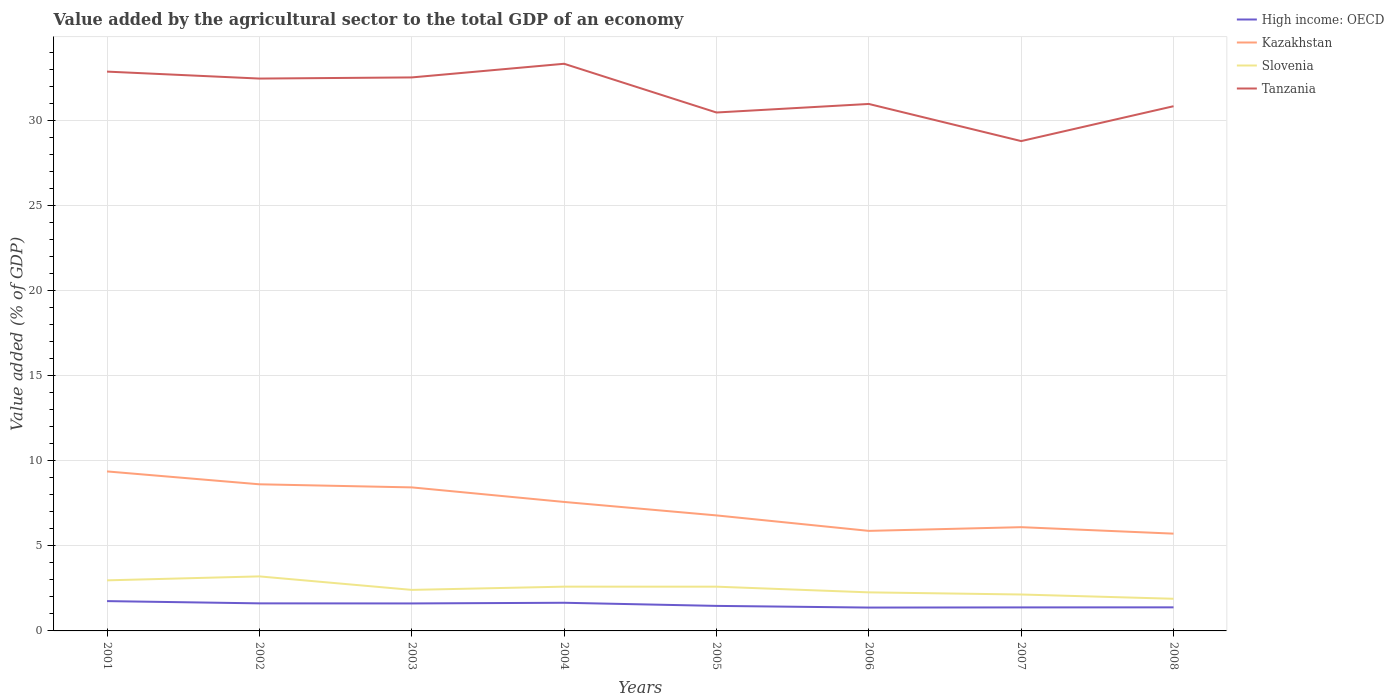How many different coloured lines are there?
Offer a very short reply. 4. Is the number of lines equal to the number of legend labels?
Provide a short and direct response. Yes. Across all years, what is the maximum value added by the agricultural sector to the total GDP in Kazakhstan?
Provide a succinct answer. 5.72. In which year was the value added by the agricultural sector to the total GDP in Slovenia maximum?
Offer a terse response. 2008. What is the total value added by the agricultural sector to the total GDP in Tanzania in the graph?
Ensure brevity in your answer.  3.74. What is the difference between the highest and the second highest value added by the agricultural sector to the total GDP in Slovenia?
Offer a terse response. 1.31. Is the value added by the agricultural sector to the total GDP in Kazakhstan strictly greater than the value added by the agricultural sector to the total GDP in Tanzania over the years?
Offer a very short reply. Yes. How many lines are there?
Offer a terse response. 4. How many years are there in the graph?
Provide a short and direct response. 8. What is the difference between two consecutive major ticks on the Y-axis?
Give a very brief answer. 5. Does the graph contain any zero values?
Your answer should be compact. No. Does the graph contain grids?
Offer a terse response. Yes. Where does the legend appear in the graph?
Provide a short and direct response. Top right. What is the title of the graph?
Offer a very short reply. Value added by the agricultural sector to the total GDP of an economy. Does "Belize" appear as one of the legend labels in the graph?
Make the answer very short. No. What is the label or title of the Y-axis?
Your answer should be very brief. Value added (% of GDP). What is the Value added (% of GDP) of High income: OECD in 2001?
Your answer should be very brief. 1.75. What is the Value added (% of GDP) of Kazakhstan in 2001?
Ensure brevity in your answer.  9.37. What is the Value added (% of GDP) of Slovenia in 2001?
Give a very brief answer. 2.97. What is the Value added (% of GDP) in Tanzania in 2001?
Your response must be concise. 32.87. What is the Value added (% of GDP) of High income: OECD in 2002?
Make the answer very short. 1.62. What is the Value added (% of GDP) of Kazakhstan in 2002?
Keep it short and to the point. 8.62. What is the Value added (% of GDP) of Slovenia in 2002?
Give a very brief answer. 3.2. What is the Value added (% of GDP) in Tanzania in 2002?
Ensure brevity in your answer.  32.46. What is the Value added (% of GDP) of High income: OECD in 2003?
Make the answer very short. 1.62. What is the Value added (% of GDP) of Kazakhstan in 2003?
Offer a very short reply. 8.43. What is the Value added (% of GDP) of Slovenia in 2003?
Make the answer very short. 2.41. What is the Value added (% of GDP) in Tanzania in 2003?
Offer a very short reply. 32.53. What is the Value added (% of GDP) in High income: OECD in 2004?
Make the answer very short. 1.65. What is the Value added (% of GDP) of Kazakhstan in 2004?
Offer a terse response. 7.58. What is the Value added (% of GDP) of Slovenia in 2004?
Offer a very short reply. 2.6. What is the Value added (% of GDP) in Tanzania in 2004?
Keep it short and to the point. 33.33. What is the Value added (% of GDP) in High income: OECD in 2005?
Ensure brevity in your answer.  1.47. What is the Value added (% of GDP) of Kazakhstan in 2005?
Provide a short and direct response. 6.79. What is the Value added (% of GDP) of Slovenia in 2005?
Your response must be concise. 2.6. What is the Value added (% of GDP) in Tanzania in 2005?
Make the answer very short. 30.46. What is the Value added (% of GDP) of High income: OECD in 2006?
Keep it short and to the point. 1.37. What is the Value added (% of GDP) of Kazakhstan in 2006?
Offer a terse response. 5.88. What is the Value added (% of GDP) in Slovenia in 2006?
Give a very brief answer. 2.27. What is the Value added (% of GDP) of Tanzania in 2006?
Make the answer very short. 30.97. What is the Value added (% of GDP) in High income: OECD in 2007?
Make the answer very short. 1.38. What is the Value added (% of GDP) of Kazakhstan in 2007?
Your response must be concise. 6.1. What is the Value added (% of GDP) in Slovenia in 2007?
Your answer should be very brief. 2.14. What is the Value added (% of GDP) of Tanzania in 2007?
Provide a succinct answer. 28.78. What is the Value added (% of GDP) in High income: OECD in 2008?
Ensure brevity in your answer.  1.39. What is the Value added (% of GDP) of Kazakhstan in 2008?
Offer a very short reply. 5.72. What is the Value added (% of GDP) in Slovenia in 2008?
Offer a terse response. 1.89. What is the Value added (% of GDP) of Tanzania in 2008?
Offer a terse response. 30.83. Across all years, what is the maximum Value added (% of GDP) in High income: OECD?
Make the answer very short. 1.75. Across all years, what is the maximum Value added (% of GDP) of Kazakhstan?
Keep it short and to the point. 9.37. Across all years, what is the maximum Value added (% of GDP) in Slovenia?
Give a very brief answer. 3.2. Across all years, what is the maximum Value added (% of GDP) of Tanzania?
Provide a succinct answer. 33.33. Across all years, what is the minimum Value added (% of GDP) in High income: OECD?
Provide a short and direct response. 1.37. Across all years, what is the minimum Value added (% of GDP) of Kazakhstan?
Provide a short and direct response. 5.72. Across all years, what is the minimum Value added (% of GDP) of Slovenia?
Offer a terse response. 1.89. Across all years, what is the minimum Value added (% of GDP) in Tanzania?
Keep it short and to the point. 28.78. What is the total Value added (% of GDP) in High income: OECD in the graph?
Offer a very short reply. 12.25. What is the total Value added (% of GDP) in Kazakhstan in the graph?
Keep it short and to the point. 58.48. What is the total Value added (% of GDP) of Slovenia in the graph?
Offer a very short reply. 20.08. What is the total Value added (% of GDP) in Tanzania in the graph?
Offer a terse response. 252.23. What is the difference between the Value added (% of GDP) of High income: OECD in 2001 and that in 2002?
Provide a succinct answer. 0.13. What is the difference between the Value added (% of GDP) in Kazakhstan in 2001 and that in 2002?
Your answer should be very brief. 0.76. What is the difference between the Value added (% of GDP) in Slovenia in 2001 and that in 2002?
Ensure brevity in your answer.  -0.23. What is the difference between the Value added (% of GDP) in Tanzania in 2001 and that in 2002?
Your answer should be very brief. 0.41. What is the difference between the Value added (% of GDP) in High income: OECD in 2001 and that in 2003?
Provide a short and direct response. 0.14. What is the difference between the Value added (% of GDP) in Kazakhstan in 2001 and that in 2003?
Ensure brevity in your answer.  0.94. What is the difference between the Value added (% of GDP) of Slovenia in 2001 and that in 2003?
Offer a very short reply. 0.56. What is the difference between the Value added (% of GDP) of Tanzania in 2001 and that in 2003?
Give a very brief answer. 0.34. What is the difference between the Value added (% of GDP) of High income: OECD in 2001 and that in 2004?
Give a very brief answer. 0.1. What is the difference between the Value added (% of GDP) of Kazakhstan in 2001 and that in 2004?
Your answer should be compact. 1.79. What is the difference between the Value added (% of GDP) of Slovenia in 2001 and that in 2004?
Provide a succinct answer. 0.37. What is the difference between the Value added (% of GDP) of Tanzania in 2001 and that in 2004?
Provide a succinct answer. -0.46. What is the difference between the Value added (% of GDP) of High income: OECD in 2001 and that in 2005?
Your answer should be compact. 0.28. What is the difference between the Value added (% of GDP) in Kazakhstan in 2001 and that in 2005?
Your response must be concise. 2.58. What is the difference between the Value added (% of GDP) in Slovenia in 2001 and that in 2005?
Your answer should be very brief. 0.37. What is the difference between the Value added (% of GDP) in Tanzania in 2001 and that in 2005?
Offer a very short reply. 2.4. What is the difference between the Value added (% of GDP) of High income: OECD in 2001 and that in 2006?
Your response must be concise. 0.38. What is the difference between the Value added (% of GDP) in Kazakhstan in 2001 and that in 2006?
Ensure brevity in your answer.  3.49. What is the difference between the Value added (% of GDP) in Slovenia in 2001 and that in 2006?
Offer a very short reply. 0.71. What is the difference between the Value added (% of GDP) in Tanzania in 2001 and that in 2006?
Provide a succinct answer. 1.9. What is the difference between the Value added (% of GDP) in High income: OECD in 2001 and that in 2007?
Your answer should be very brief. 0.37. What is the difference between the Value added (% of GDP) of Kazakhstan in 2001 and that in 2007?
Offer a terse response. 3.28. What is the difference between the Value added (% of GDP) of Slovenia in 2001 and that in 2007?
Give a very brief answer. 0.83. What is the difference between the Value added (% of GDP) of Tanzania in 2001 and that in 2007?
Provide a succinct answer. 4.08. What is the difference between the Value added (% of GDP) of High income: OECD in 2001 and that in 2008?
Your answer should be very brief. 0.37. What is the difference between the Value added (% of GDP) of Kazakhstan in 2001 and that in 2008?
Provide a succinct answer. 3.66. What is the difference between the Value added (% of GDP) in Slovenia in 2001 and that in 2008?
Give a very brief answer. 1.08. What is the difference between the Value added (% of GDP) in Tanzania in 2001 and that in 2008?
Offer a terse response. 2.03. What is the difference between the Value added (% of GDP) in High income: OECD in 2002 and that in 2003?
Your answer should be very brief. 0. What is the difference between the Value added (% of GDP) of Kazakhstan in 2002 and that in 2003?
Your answer should be very brief. 0.18. What is the difference between the Value added (% of GDP) of Slovenia in 2002 and that in 2003?
Provide a short and direct response. 0.79. What is the difference between the Value added (% of GDP) in Tanzania in 2002 and that in 2003?
Offer a very short reply. -0.07. What is the difference between the Value added (% of GDP) in High income: OECD in 2002 and that in 2004?
Keep it short and to the point. -0.03. What is the difference between the Value added (% of GDP) of Kazakhstan in 2002 and that in 2004?
Your answer should be compact. 1.04. What is the difference between the Value added (% of GDP) in Slovenia in 2002 and that in 2004?
Your answer should be very brief. 0.6. What is the difference between the Value added (% of GDP) in Tanzania in 2002 and that in 2004?
Your answer should be compact. -0.87. What is the difference between the Value added (% of GDP) of High income: OECD in 2002 and that in 2005?
Your answer should be very brief. 0.15. What is the difference between the Value added (% of GDP) in Kazakhstan in 2002 and that in 2005?
Your answer should be compact. 1.83. What is the difference between the Value added (% of GDP) in Slovenia in 2002 and that in 2005?
Provide a short and direct response. 0.6. What is the difference between the Value added (% of GDP) in Tanzania in 2002 and that in 2005?
Your answer should be very brief. 1.99. What is the difference between the Value added (% of GDP) in High income: OECD in 2002 and that in 2006?
Your answer should be compact. 0.25. What is the difference between the Value added (% of GDP) of Kazakhstan in 2002 and that in 2006?
Your answer should be compact. 2.74. What is the difference between the Value added (% of GDP) in Slovenia in 2002 and that in 2006?
Give a very brief answer. 0.94. What is the difference between the Value added (% of GDP) in Tanzania in 2002 and that in 2006?
Make the answer very short. 1.49. What is the difference between the Value added (% of GDP) in High income: OECD in 2002 and that in 2007?
Ensure brevity in your answer.  0.24. What is the difference between the Value added (% of GDP) of Kazakhstan in 2002 and that in 2007?
Give a very brief answer. 2.52. What is the difference between the Value added (% of GDP) in Slovenia in 2002 and that in 2007?
Give a very brief answer. 1.06. What is the difference between the Value added (% of GDP) in Tanzania in 2002 and that in 2007?
Provide a short and direct response. 3.67. What is the difference between the Value added (% of GDP) in High income: OECD in 2002 and that in 2008?
Your answer should be very brief. 0.23. What is the difference between the Value added (% of GDP) of Kazakhstan in 2002 and that in 2008?
Offer a very short reply. 2.9. What is the difference between the Value added (% of GDP) of Slovenia in 2002 and that in 2008?
Give a very brief answer. 1.31. What is the difference between the Value added (% of GDP) in Tanzania in 2002 and that in 2008?
Provide a succinct answer. 1.62. What is the difference between the Value added (% of GDP) in High income: OECD in 2003 and that in 2004?
Provide a succinct answer. -0.04. What is the difference between the Value added (% of GDP) of Kazakhstan in 2003 and that in 2004?
Your answer should be very brief. 0.86. What is the difference between the Value added (% of GDP) of Slovenia in 2003 and that in 2004?
Keep it short and to the point. -0.19. What is the difference between the Value added (% of GDP) in Tanzania in 2003 and that in 2004?
Offer a terse response. -0.8. What is the difference between the Value added (% of GDP) of High income: OECD in 2003 and that in 2005?
Your answer should be very brief. 0.14. What is the difference between the Value added (% of GDP) in Kazakhstan in 2003 and that in 2005?
Offer a very short reply. 1.65. What is the difference between the Value added (% of GDP) in Slovenia in 2003 and that in 2005?
Keep it short and to the point. -0.19. What is the difference between the Value added (% of GDP) of Tanzania in 2003 and that in 2005?
Keep it short and to the point. 2.06. What is the difference between the Value added (% of GDP) in High income: OECD in 2003 and that in 2006?
Offer a terse response. 0.24. What is the difference between the Value added (% of GDP) in Kazakhstan in 2003 and that in 2006?
Make the answer very short. 2.56. What is the difference between the Value added (% of GDP) of Slovenia in 2003 and that in 2006?
Your answer should be very brief. 0.15. What is the difference between the Value added (% of GDP) in Tanzania in 2003 and that in 2006?
Provide a short and direct response. 1.56. What is the difference between the Value added (% of GDP) in High income: OECD in 2003 and that in 2007?
Make the answer very short. 0.23. What is the difference between the Value added (% of GDP) of Kazakhstan in 2003 and that in 2007?
Make the answer very short. 2.34. What is the difference between the Value added (% of GDP) in Slovenia in 2003 and that in 2007?
Make the answer very short. 0.27. What is the difference between the Value added (% of GDP) in Tanzania in 2003 and that in 2007?
Offer a terse response. 3.74. What is the difference between the Value added (% of GDP) in High income: OECD in 2003 and that in 2008?
Give a very brief answer. 0.23. What is the difference between the Value added (% of GDP) in Kazakhstan in 2003 and that in 2008?
Make the answer very short. 2.72. What is the difference between the Value added (% of GDP) of Slovenia in 2003 and that in 2008?
Provide a succinct answer. 0.52. What is the difference between the Value added (% of GDP) in Tanzania in 2003 and that in 2008?
Offer a very short reply. 1.69. What is the difference between the Value added (% of GDP) in High income: OECD in 2004 and that in 2005?
Provide a succinct answer. 0.18. What is the difference between the Value added (% of GDP) of Kazakhstan in 2004 and that in 2005?
Ensure brevity in your answer.  0.79. What is the difference between the Value added (% of GDP) of Slovenia in 2004 and that in 2005?
Give a very brief answer. 0. What is the difference between the Value added (% of GDP) of Tanzania in 2004 and that in 2005?
Your response must be concise. 2.86. What is the difference between the Value added (% of GDP) in High income: OECD in 2004 and that in 2006?
Keep it short and to the point. 0.28. What is the difference between the Value added (% of GDP) in Kazakhstan in 2004 and that in 2006?
Your answer should be very brief. 1.7. What is the difference between the Value added (% of GDP) of Slovenia in 2004 and that in 2006?
Ensure brevity in your answer.  0.34. What is the difference between the Value added (% of GDP) in Tanzania in 2004 and that in 2006?
Your answer should be compact. 2.36. What is the difference between the Value added (% of GDP) in High income: OECD in 2004 and that in 2007?
Give a very brief answer. 0.27. What is the difference between the Value added (% of GDP) of Kazakhstan in 2004 and that in 2007?
Offer a very short reply. 1.48. What is the difference between the Value added (% of GDP) in Slovenia in 2004 and that in 2007?
Offer a very short reply. 0.46. What is the difference between the Value added (% of GDP) of Tanzania in 2004 and that in 2007?
Ensure brevity in your answer.  4.54. What is the difference between the Value added (% of GDP) of High income: OECD in 2004 and that in 2008?
Offer a terse response. 0.27. What is the difference between the Value added (% of GDP) of Kazakhstan in 2004 and that in 2008?
Provide a short and direct response. 1.86. What is the difference between the Value added (% of GDP) in Slovenia in 2004 and that in 2008?
Offer a very short reply. 0.71. What is the difference between the Value added (% of GDP) of Tanzania in 2004 and that in 2008?
Give a very brief answer. 2.49. What is the difference between the Value added (% of GDP) in High income: OECD in 2005 and that in 2006?
Ensure brevity in your answer.  0.1. What is the difference between the Value added (% of GDP) in Kazakhstan in 2005 and that in 2006?
Provide a succinct answer. 0.91. What is the difference between the Value added (% of GDP) of Slovenia in 2005 and that in 2006?
Offer a very short reply. 0.33. What is the difference between the Value added (% of GDP) in Tanzania in 2005 and that in 2006?
Give a very brief answer. -0.5. What is the difference between the Value added (% of GDP) of High income: OECD in 2005 and that in 2007?
Offer a very short reply. 0.09. What is the difference between the Value added (% of GDP) in Kazakhstan in 2005 and that in 2007?
Offer a very short reply. 0.69. What is the difference between the Value added (% of GDP) in Slovenia in 2005 and that in 2007?
Ensure brevity in your answer.  0.46. What is the difference between the Value added (% of GDP) of Tanzania in 2005 and that in 2007?
Keep it short and to the point. 1.68. What is the difference between the Value added (% of GDP) of High income: OECD in 2005 and that in 2008?
Provide a short and direct response. 0.09. What is the difference between the Value added (% of GDP) in Kazakhstan in 2005 and that in 2008?
Provide a short and direct response. 1.07. What is the difference between the Value added (% of GDP) in Slovenia in 2005 and that in 2008?
Offer a terse response. 0.71. What is the difference between the Value added (% of GDP) of Tanzania in 2005 and that in 2008?
Your answer should be very brief. -0.37. What is the difference between the Value added (% of GDP) in High income: OECD in 2006 and that in 2007?
Your response must be concise. -0.01. What is the difference between the Value added (% of GDP) in Kazakhstan in 2006 and that in 2007?
Provide a short and direct response. -0.22. What is the difference between the Value added (% of GDP) in Slovenia in 2006 and that in 2007?
Your answer should be very brief. 0.13. What is the difference between the Value added (% of GDP) of Tanzania in 2006 and that in 2007?
Your answer should be compact. 2.18. What is the difference between the Value added (% of GDP) in High income: OECD in 2006 and that in 2008?
Give a very brief answer. -0.01. What is the difference between the Value added (% of GDP) of Kazakhstan in 2006 and that in 2008?
Keep it short and to the point. 0.16. What is the difference between the Value added (% of GDP) of Slovenia in 2006 and that in 2008?
Make the answer very short. 0.38. What is the difference between the Value added (% of GDP) of Tanzania in 2006 and that in 2008?
Offer a very short reply. 0.13. What is the difference between the Value added (% of GDP) of High income: OECD in 2007 and that in 2008?
Give a very brief answer. -0. What is the difference between the Value added (% of GDP) of Kazakhstan in 2007 and that in 2008?
Your response must be concise. 0.38. What is the difference between the Value added (% of GDP) of Slovenia in 2007 and that in 2008?
Your response must be concise. 0.25. What is the difference between the Value added (% of GDP) in Tanzania in 2007 and that in 2008?
Your response must be concise. -2.05. What is the difference between the Value added (% of GDP) of High income: OECD in 2001 and the Value added (% of GDP) of Kazakhstan in 2002?
Your answer should be very brief. -6.86. What is the difference between the Value added (% of GDP) of High income: OECD in 2001 and the Value added (% of GDP) of Slovenia in 2002?
Ensure brevity in your answer.  -1.45. What is the difference between the Value added (% of GDP) in High income: OECD in 2001 and the Value added (% of GDP) in Tanzania in 2002?
Offer a very short reply. -30.71. What is the difference between the Value added (% of GDP) in Kazakhstan in 2001 and the Value added (% of GDP) in Slovenia in 2002?
Offer a terse response. 6.17. What is the difference between the Value added (% of GDP) of Kazakhstan in 2001 and the Value added (% of GDP) of Tanzania in 2002?
Your response must be concise. -23.09. What is the difference between the Value added (% of GDP) in Slovenia in 2001 and the Value added (% of GDP) in Tanzania in 2002?
Make the answer very short. -29.49. What is the difference between the Value added (% of GDP) of High income: OECD in 2001 and the Value added (% of GDP) of Kazakhstan in 2003?
Provide a succinct answer. -6.68. What is the difference between the Value added (% of GDP) in High income: OECD in 2001 and the Value added (% of GDP) in Slovenia in 2003?
Ensure brevity in your answer.  -0.66. What is the difference between the Value added (% of GDP) of High income: OECD in 2001 and the Value added (% of GDP) of Tanzania in 2003?
Give a very brief answer. -30.77. What is the difference between the Value added (% of GDP) in Kazakhstan in 2001 and the Value added (% of GDP) in Slovenia in 2003?
Give a very brief answer. 6.96. What is the difference between the Value added (% of GDP) in Kazakhstan in 2001 and the Value added (% of GDP) in Tanzania in 2003?
Make the answer very short. -23.15. What is the difference between the Value added (% of GDP) in Slovenia in 2001 and the Value added (% of GDP) in Tanzania in 2003?
Give a very brief answer. -29.55. What is the difference between the Value added (% of GDP) in High income: OECD in 2001 and the Value added (% of GDP) in Kazakhstan in 2004?
Your answer should be compact. -5.83. What is the difference between the Value added (% of GDP) of High income: OECD in 2001 and the Value added (% of GDP) of Slovenia in 2004?
Ensure brevity in your answer.  -0.85. What is the difference between the Value added (% of GDP) in High income: OECD in 2001 and the Value added (% of GDP) in Tanzania in 2004?
Your answer should be very brief. -31.58. What is the difference between the Value added (% of GDP) in Kazakhstan in 2001 and the Value added (% of GDP) in Slovenia in 2004?
Keep it short and to the point. 6.77. What is the difference between the Value added (% of GDP) in Kazakhstan in 2001 and the Value added (% of GDP) in Tanzania in 2004?
Give a very brief answer. -23.96. What is the difference between the Value added (% of GDP) of Slovenia in 2001 and the Value added (% of GDP) of Tanzania in 2004?
Your answer should be very brief. -30.36. What is the difference between the Value added (% of GDP) in High income: OECD in 2001 and the Value added (% of GDP) in Kazakhstan in 2005?
Give a very brief answer. -5.04. What is the difference between the Value added (% of GDP) of High income: OECD in 2001 and the Value added (% of GDP) of Slovenia in 2005?
Offer a terse response. -0.85. What is the difference between the Value added (% of GDP) of High income: OECD in 2001 and the Value added (% of GDP) of Tanzania in 2005?
Your answer should be very brief. -28.71. What is the difference between the Value added (% of GDP) of Kazakhstan in 2001 and the Value added (% of GDP) of Slovenia in 2005?
Ensure brevity in your answer.  6.77. What is the difference between the Value added (% of GDP) of Kazakhstan in 2001 and the Value added (% of GDP) of Tanzania in 2005?
Your answer should be compact. -21.09. What is the difference between the Value added (% of GDP) in Slovenia in 2001 and the Value added (% of GDP) in Tanzania in 2005?
Make the answer very short. -27.49. What is the difference between the Value added (% of GDP) of High income: OECD in 2001 and the Value added (% of GDP) of Kazakhstan in 2006?
Your answer should be compact. -4.13. What is the difference between the Value added (% of GDP) of High income: OECD in 2001 and the Value added (% of GDP) of Slovenia in 2006?
Your answer should be very brief. -0.51. What is the difference between the Value added (% of GDP) of High income: OECD in 2001 and the Value added (% of GDP) of Tanzania in 2006?
Your answer should be very brief. -29.21. What is the difference between the Value added (% of GDP) of Kazakhstan in 2001 and the Value added (% of GDP) of Slovenia in 2006?
Offer a terse response. 7.11. What is the difference between the Value added (% of GDP) of Kazakhstan in 2001 and the Value added (% of GDP) of Tanzania in 2006?
Make the answer very short. -21.59. What is the difference between the Value added (% of GDP) of Slovenia in 2001 and the Value added (% of GDP) of Tanzania in 2006?
Ensure brevity in your answer.  -27.99. What is the difference between the Value added (% of GDP) in High income: OECD in 2001 and the Value added (% of GDP) in Kazakhstan in 2007?
Your response must be concise. -4.34. What is the difference between the Value added (% of GDP) of High income: OECD in 2001 and the Value added (% of GDP) of Slovenia in 2007?
Make the answer very short. -0.39. What is the difference between the Value added (% of GDP) in High income: OECD in 2001 and the Value added (% of GDP) in Tanzania in 2007?
Ensure brevity in your answer.  -27.03. What is the difference between the Value added (% of GDP) in Kazakhstan in 2001 and the Value added (% of GDP) in Slovenia in 2007?
Your answer should be compact. 7.23. What is the difference between the Value added (% of GDP) of Kazakhstan in 2001 and the Value added (% of GDP) of Tanzania in 2007?
Your response must be concise. -19.41. What is the difference between the Value added (% of GDP) of Slovenia in 2001 and the Value added (% of GDP) of Tanzania in 2007?
Provide a succinct answer. -25.81. What is the difference between the Value added (% of GDP) of High income: OECD in 2001 and the Value added (% of GDP) of Kazakhstan in 2008?
Your answer should be compact. -3.96. What is the difference between the Value added (% of GDP) in High income: OECD in 2001 and the Value added (% of GDP) in Slovenia in 2008?
Your answer should be compact. -0.14. What is the difference between the Value added (% of GDP) in High income: OECD in 2001 and the Value added (% of GDP) in Tanzania in 2008?
Offer a very short reply. -29.08. What is the difference between the Value added (% of GDP) of Kazakhstan in 2001 and the Value added (% of GDP) of Slovenia in 2008?
Provide a succinct answer. 7.48. What is the difference between the Value added (% of GDP) of Kazakhstan in 2001 and the Value added (% of GDP) of Tanzania in 2008?
Provide a short and direct response. -21.46. What is the difference between the Value added (% of GDP) of Slovenia in 2001 and the Value added (% of GDP) of Tanzania in 2008?
Offer a terse response. -27.86. What is the difference between the Value added (% of GDP) in High income: OECD in 2002 and the Value added (% of GDP) in Kazakhstan in 2003?
Make the answer very short. -6.81. What is the difference between the Value added (% of GDP) of High income: OECD in 2002 and the Value added (% of GDP) of Slovenia in 2003?
Give a very brief answer. -0.79. What is the difference between the Value added (% of GDP) in High income: OECD in 2002 and the Value added (% of GDP) in Tanzania in 2003?
Provide a succinct answer. -30.91. What is the difference between the Value added (% of GDP) of Kazakhstan in 2002 and the Value added (% of GDP) of Slovenia in 2003?
Ensure brevity in your answer.  6.2. What is the difference between the Value added (% of GDP) in Kazakhstan in 2002 and the Value added (% of GDP) in Tanzania in 2003?
Keep it short and to the point. -23.91. What is the difference between the Value added (% of GDP) in Slovenia in 2002 and the Value added (% of GDP) in Tanzania in 2003?
Offer a terse response. -29.32. What is the difference between the Value added (% of GDP) in High income: OECD in 2002 and the Value added (% of GDP) in Kazakhstan in 2004?
Your answer should be compact. -5.96. What is the difference between the Value added (% of GDP) of High income: OECD in 2002 and the Value added (% of GDP) of Slovenia in 2004?
Your response must be concise. -0.98. What is the difference between the Value added (% of GDP) in High income: OECD in 2002 and the Value added (% of GDP) in Tanzania in 2004?
Provide a short and direct response. -31.71. What is the difference between the Value added (% of GDP) of Kazakhstan in 2002 and the Value added (% of GDP) of Slovenia in 2004?
Provide a succinct answer. 6.01. What is the difference between the Value added (% of GDP) of Kazakhstan in 2002 and the Value added (% of GDP) of Tanzania in 2004?
Make the answer very short. -24.71. What is the difference between the Value added (% of GDP) in Slovenia in 2002 and the Value added (% of GDP) in Tanzania in 2004?
Provide a short and direct response. -30.12. What is the difference between the Value added (% of GDP) in High income: OECD in 2002 and the Value added (% of GDP) in Kazakhstan in 2005?
Offer a very short reply. -5.17. What is the difference between the Value added (% of GDP) in High income: OECD in 2002 and the Value added (% of GDP) in Slovenia in 2005?
Provide a short and direct response. -0.98. What is the difference between the Value added (% of GDP) of High income: OECD in 2002 and the Value added (% of GDP) of Tanzania in 2005?
Your answer should be compact. -28.84. What is the difference between the Value added (% of GDP) in Kazakhstan in 2002 and the Value added (% of GDP) in Slovenia in 2005?
Provide a short and direct response. 6.02. What is the difference between the Value added (% of GDP) in Kazakhstan in 2002 and the Value added (% of GDP) in Tanzania in 2005?
Make the answer very short. -21.85. What is the difference between the Value added (% of GDP) in Slovenia in 2002 and the Value added (% of GDP) in Tanzania in 2005?
Your response must be concise. -27.26. What is the difference between the Value added (% of GDP) in High income: OECD in 2002 and the Value added (% of GDP) in Kazakhstan in 2006?
Give a very brief answer. -4.26. What is the difference between the Value added (% of GDP) in High income: OECD in 2002 and the Value added (% of GDP) in Slovenia in 2006?
Provide a short and direct response. -0.65. What is the difference between the Value added (% of GDP) in High income: OECD in 2002 and the Value added (% of GDP) in Tanzania in 2006?
Keep it short and to the point. -29.35. What is the difference between the Value added (% of GDP) in Kazakhstan in 2002 and the Value added (% of GDP) in Slovenia in 2006?
Ensure brevity in your answer.  6.35. What is the difference between the Value added (% of GDP) in Kazakhstan in 2002 and the Value added (% of GDP) in Tanzania in 2006?
Ensure brevity in your answer.  -22.35. What is the difference between the Value added (% of GDP) in Slovenia in 2002 and the Value added (% of GDP) in Tanzania in 2006?
Provide a succinct answer. -27.76. What is the difference between the Value added (% of GDP) in High income: OECD in 2002 and the Value added (% of GDP) in Kazakhstan in 2007?
Provide a short and direct response. -4.48. What is the difference between the Value added (% of GDP) of High income: OECD in 2002 and the Value added (% of GDP) of Slovenia in 2007?
Your response must be concise. -0.52. What is the difference between the Value added (% of GDP) of High income: OECD in 2002 and the Value added (% of GDP) of Tanzania in 2007?
Provide a succinct answer. -27.16. What is the difference between the Value added (% of GDP) of Kazakhstan in 2002 and the Value added (% of GDP) of Slovenia in 2007?
Offer a terse response. 6.48. What is the difference between the Value added (% of GDP) of Kazakhstan in 2002 and the Value added (% of GDP) of Tanzania in 2007?
Provide a short and direct response. -20.17. What is the difference between the Value added (% of GDP) of Slovenia in 2002 and the Value added (% of GDP) of Tanzania in 2007?
Offer a terse response. -25.58. What is the difference between the Value added (% of GDP) of High income: OECD in 2002 and the Value added (% of GDP) of Kazakhstan in 2008?
Provide a succinct answer. -4.1. What is the difference between the Value added (% of GDP) of High income: OECD in 2002 and the Value added (% of GDP) of Slovenia in 2008?
Make the answer very short. -0.27. What is the difference between the Value added (% of GDP) of High income: OECD in 2002 and the Value added (% of GDP) of Tanzania in 2008?
Your response must be concise. -29.21. What is the difference between the Value added (% of GDP) in Kazakhstan in 2002 and the Value added (% of GDP) in Slovenia in 2008?
Give a very brief answer. 6.73. What is the difference between the Value added (% of GDP) of Kazakhstan in 2002 and the Value added (% of GDP) of Tanzania in 2008?
Provide a succinct answer. -22.22. What is the difference between the Value added (% of GDP) of Slovenia in 2002 and the Value added (% of GDP) of Tanzania in 2008?
Ensure brevity in your answer.  -27.63. What is the difference between the Value added (% of GDP) of High income: OECD in 2003 and the Value added (% of GDP) of Kazakhstan in 2004?
Your answer should be compact. -5.96. What is the difference between the Value added (% of GDP) of High income: OECD in 2003 and the Value added (% of GDP) of Slovenia in 2004?
Your answer should be very brief. -0.99. What is the difference between the Value added (% of GDP) of High income: OECD in 2003 and the Value added (% of GDP) of Tanzania in 2004?
Your answer should be compact. -31.71. What is the difference between the Value added (% of GDP) in Kazakhstan in 2003 and the Value added (% of GDP) in Slovenia in 2004?
Your answer should be very brief. 5.83. What is the difference between the Value added (% of GDP) in Kazakhstan in 2003 and the Value added (% of GDP) in Tanzania in 2004?
Provide a succinct answer. -24.89. What is the difference between the Value added (% of GDP) in Slovenia in 2003 and the Value added (% of GDP) in Tanzania in 2004?
Your answer should be very brief. -30.92. What is the difference between the Value added (% of GDP) of High income: OECD in 2003 and the Value added (% of GDP) of Kazakhstan in 2005?
Offer a very short reply. -5.17. What is the difference between the Value added (% of GDP) in High income: OECD in 2003 and the Value added (% of GDP) in Slovenia in 2005?
Make the answer very short. -0.99. What is the difference between the Value added (% of GDP) in High income: OECD in 2003 and the Value added (% of GDP) in Tanzania in 2005?
Offer a very short reply. -28.85. What is the difference between the Value added (% of GDP) of Kazakhstan in 2003 and the Value added (% of GDP) of Slovenia in 2005?
Your answer should be compact. 5.83. What is the difference between the Value added (% of GDP) of Kazakhstan in 2003 and the Value added (% of GDP) of Tanzania in 2005?
Give a very brief answer. -22.03. What is the difference between the Value added (% of GDP) in Slovenia in 2003 and the Value added (% of GDP) in Tanzania in 2005?
Keep it short and to the point. -28.05. What is the difference between the Value added (% of GDP) of High income: OECD in 2003 and the Value added (% of GDP) of Kazakhstan in 2006?
Your response must be concise. -4.26. What is the difference between the Value added (% of GDP) in High income: OECD in 2003 and the Value added (% of GDP) in Slovenia in 2006?
Your answer should be compact. -0.65. What is the difference between the Value added (% of GDP) in High income: OECD in 2003 and the Value added (% of GDP) in Tanzania in 2006?
Ensure brevity in your answer.  -29.35. What is the difference between the Value added (% of GDP) in Kazakhstan in 2003 and the Value added (% of GDP) in Slovenia in 2006?
Make the answer very short. 6.17. What is the difference between the Value added (% of GDP) of Kazakhstan in 2003 and the Value added (% of GDP) of Tanzania in 2006?
Your response must be concise. -22.53. What is the difference between the Value added (% of GDP) in Slovenia in 2003 and the Value added (% of GDP) in Tanzania in 2006?
Offer a very short reply. -28.55. What is the difference between the Value added (% of GDP) in High income: OECD in 2003 and the Value added (% of GDP) in Kazakhstan in 2007?
Ensure brevity in your answer.  -4.48. What is the difference between the Value added (% of GDP) in High income: OECD in 2003 and the Value added (% of GDP) in Slovenia in 2007?
Your response must be concise. -0.52. What is the difference between the Value added (% of GDP) in High income: OECD in 2003 and the Value added (% of GDP) in Tanzania in 2007?
Keep it short and to the point. -27.17. What is the difference between the Value added (% of GDP) in Kazakhstan in 2003 and the Value added (% of GDP) in Slovenia in 2007?
Offer a very short reply. 6.29. What is the difference between the Value added (% of GDP) of Kazakhstan in 2003 and the Value added (% of GDP) of Tanzania in 2007?
Offer a very short reply. -20.35. What is the difference between the Value added (% of GDP) in Slovenia in 2003 and the Value added (% of GDP) in Tanzania in 2007?
Your response must be concise. -26.37. What is the difference between the Value added (% of GDP) of High income: OECD in 2003 and the Value added (% of GDP) of Kazakhstan in 2008?
Your response must be concise. -4.1. What is the difference between the Value added (% of GDP) of High income: OECD in 2003 and the Value added (% of GDP) of Slovenia in 2008?
Provide a succinct answer. -0.27. What is the difference between the Value added (% of GDP) of High income: OECD in 2003 and the Value added (% of GDP) of Tanzania in 2008?
Make the answer very short. -29.22. What is the difference between the Value added (% of GDP) of Kazakhstan in 2003 and the Value added (% of GDP) of Slovenia in 2008?
Give a very brief answer. 6.54. What is the difference between the Value added (% of GDP) in Kazakhstan in 2003 and the Value added (% of GDP) in Tanzania in 2008?
Your answer should be compact. -22.4. What is the difference between the Value added (% of GDP) of Slovenia in 2003 and the Value added (% of GDP) of Tanzania in 2008?
Offer a very short reply. -28.42. What is the difference between the Value added (% of GDP) in High income: OECD in 2004 and the Value added (% of GDP) in Kazakhstan in 2005?
Ensure brevity in your answer.  -5.13. What is the difference between the Value added (% of GDP) in High income: OECD in 2004 and the Value added (% of GDP) in Slovenia in 2005?
Make the answer very short. -0.95. What is the difference between the Value added (% of GDP) in High income: OECD in 2004 and the Value added (% of GDP) in Tanzania in 2005?
Give a very brief answer. -28.81. What is the difference between the Value added (% of GDP) in Kazakhstan in 2004 and the Value added (% of GDP) in Slovenia in 2005?
Your response must be concise. 4.98. What is the difference between the Value added (% of GDP) in Kazakhstan in 2004 and the Value added (% of GDP) in Tanzania in 2005?
Provide a succinct answer. -22.89. What is the difference between the Value added (% of GDP) in Slovenia in 2004 and the Value added (% of GDP) in Tanzania in 2005?
Provide a short and direct response. -27.86. What is the difference between the Value added (% of GDP) of High income: OECD in 2004 and the Value added (% of GDP) of Kazakhstan in 2006?
Your response must be concise. -4.22. What is the difference between the Value added (% of GDP) in High income: OECD in 2004 and the Value added (% of GDP) in Slovenia in 2006?
Your response must be concise. -0.61. What is the difference between the Value added (% of GDP) in High income: OECD in 2004 and the Value added (% of GDP) in Tanzania in 2006?
Provide a succinct answer. -29.31. What is the difference between the Value added (% of GDP) in Kazakhstan in 2004 and the Value added (% of GDP) in Slovenia in 2006?
Give a very brief answer. 5.31. What is the difference between the Value added (% of GDP) of Kazakhstan in 2004 and the Value added (% of GDP) of Tanzania in 2006?
Your answer should be very brief. -23.39. What is the difference between the Value added (% of GDP) in Slovenia in 2004 and the Value added (% of GDP) in Tanzania in 2006?
Provide a succinct answer. -28.36. What is the difference between the Value added (% of GDP) of High income: OECD in 2004 and the Value added (% of GDP) of Kazakhstan in 2007?
Your response must be concise. -4.44. What is the difference between the Value added (% of GDP) in High income: OECD in 2004 and the Value added (% of GDP) in Slovenia in 2007?
Give a very brief answer. -0.49. What is the difference between the Value added (% of GDP) of High income: OECD in 2004 and the Value added (% of GDP) of Tanzania in 2007?
Provide a succinct answer. -27.13. What is the difference between the Value added (% of GDP) of Kazakhstan in 2004 and the Value added (% of GDP) of Slovenia in 2007?
Your answer should be very brief. 5.44. What is the difference between the Value added (% of GDP) of Kazakhstan in 2004 and the Value added (% of GDP) of Tanzania in 2007?
Your answer should be very brief. -21.21. What is the difference between the Value added (% of GDP) in Slovenia in 2004 and the Value added (% of GDP) in Tanzania in 2007?
Your answer should be compact. -26.18. What is the difference between the Value added (% of GDP) of High income: OECD in 2004 and the Value added (% of GDP) of Kazakhstan in 2008?
Ensure brevity in your answer.  -4.06. What is the difference between the Value added (% of GDP) of High income: OECD in 2004 and the Value added (% of GDP) of Slovenia in 2008?
Give a very brief answer. -0.24. What is the difference between the Value added (% of GDP) in High income: OECD in 2004 and the Value added (% of GDP) in Tanzania in 2008?
Provide a short and direct response. -29.18. What is the difference between the Value added (% of GDP) in Kazakhstan in 2004 and the Value added (% of GDP) in Slovenia in 2008?
Ensure brevity in your answer.  5.69. What is the difference between the Value added (% of GDP) of Kazakhstan in 2004 and the Value added (% of GDP) of Tanzania in 2008?
Your answer should be very brief. -23.25. What is the difference between the Value added (% of GDP) of Slovenia in 2004 and the Value added (% of GDP) of Tanzania in 2008?
Offer a terse response. -28.23. What is the difference between the Value added (% of GDP) of High income: OECD in 2005 and the Value added (% of GDP) of Kazakhstan in 2006?
Give a very brief answer. -4.41. What is the difference between the Value added (% of GDP) of High income: OECD in 2005 and the Value added (% of GDP) of Slovenia in 2006?
Ensure brevity in your answer.  -0.79. What is the difference between the Value added (% of GDP) of High income: OECD in 2005 and the Value added (% of GDP) of Tanzania in 2006?
Provide a short and direct response. -29.49. What is the difference between the Value added (% of GDP) in Kazakhstan in 2005 and the Value added (% of GDP) in Slovenia in 2006?
Your answer should be very brief. 4.52. What is the difference between the Value added (% of GDP) of Kazakhstan in 2005 and the Value added (% of GDP) of Tanzania in 2006?
Offer a very short reply. -24.18. What is the difference between the Value added (% of GDP) in Slovenia in 2005 and the Value added (% of GDP) in Tanzania in 2006?
Ensure brevity in your answer.  -28.37. What is the difference between the Value added (% of GDP) of High income: OECD in 2005 and the Value added (% of GDP) of Kazakhstan in 2007?
Your answer should be compact. -4.63. What is the difference between the Value added (% of GDP) of High income: OECD in 2005 and the Value added (% of GDP) of Slovenia in 2007?
Keep it short and to the point. -0.67. What is the difference between the Value added (% of GDP) of High income: OECD in 2005 and the Value added (% of GDP) of Tanzania in 2007?
Make the answer very short. -27.31. What is the difference between the Value added (% of GDP) of Kazakhstan in 2005 and the Value added (% of GDP) of Slovenia in 2007?
Your answer should be compact. 4.65. What is the difference between the Value added (% of GDP) of Kazakhstan in 2005 and the Value added (% of GDP) of Tanzania in 2007?
Give a very brief answer. -22. What is the difference between the Value added (% of GDP) of Slovenia in 2005 and the Value added (% of GDP) of Tanzania in 2007?
Provide a succinct answer. -26.18. What is the difference between the Value added (% of GDP) of High income: OECD in 2005 and the Value added (% of GDP) of Kazakhstan in 2008?
Provide a short and direct response. -4.25. What is the difference between the Value added (% of GDP) in High income: OECD in 2005 and the Value added (% of GDP) in Slovenia in 2008?
Your answer should be very brief. -0.42. What is the difference between the Value added (% of GDP) in High income: OECD in 2005 and the Value added (% of GDP) in Tanzania in 2008?
Your response must be concise. -29.36. What is the difference between the Value added (% of GDP) in Kazakhstan in 2005 and the Value added (% of GDP) in Slovenia in 2008?
Keep it short and to the point. 4.9. What is the difference between the Value added (% of GDP) in Kazakhstan in 2005 and the Value added (% of GDP) in Tanzania in 2008?
Keep it short and to the point. -24.05. What is the difference between the Value added (% of GDP) of Slovenia in 2005 and the Value added (% of GDP) of Tanzania in 2008?
Your answer should be compact. -28.23. What is the difference between the Value added (% of GDP) of High income: OECD in 2006 and the Value added (% of GDP) of Kazakhstan in 2007?
Keep it short and to the point. -4.72. What is the difference between the Value added (% of GDP) of High income: OECD in 2006 and the Value added (% of GDP) of Slovenia in 2007?
Offer a terse response. -0.77. What is the difference between the Value added (% of GDP) in High income: OECD in 2006 and the Value added (% of GDP) in Tanzania in 2007?
Offer a terse response. -27.41. What is the difference between the Value added (% of GDP) in Kazakhstan in 2006 and the Value added (% of GDP) in Slovenia in 2007?
Your response must be concise. 3.74. What is the difference between the Value added (% of GDP) of Kazakhstan in 2006 and the Value added (% of GDP) of Tanzania in 2007?
Offer a very short reply. -22.91. What is the difference between the Value added (% of GDP) of Slovenia in 2006 and the Value added (% of GDP) of Tanzania in 2007?
Provide a short and direct response. -26.52. What is the difference between the Value added (% of GDP) in High income: OECD in 2006 and the Value added (% of GDP) in Kazakhstan in 2008?
Your answer should be compact. -4.34. What is the difference between the Value added (% of GDP) of High income: OECD in 2006 and the Value added (% of GDP) of Slovenia in 2008?
Keep it short and to the point. -0.52. What is the difference between the Value added (% of GDP) in High income: OECD in 2006 and the Value added (% of GDP) in Tanzania in 2008?
Ensure brevity in your answer.  -29.46. What is the difference between the Value added (% of GDP) in Kazakhstan in 2006 and the Value added (% of GDP) in Slovenia in 2008?
Offer a terse response. 3.99. What is the difference between the Value added (% of GDP) of Kazakhstan in 2006 and the Value added (% of GDP) of Tanzania in 2008?
Offer a very short reply. -24.95. What is the difference between the Value added (% of GDP) of Slovenia in 2006 and the Value added (% of GDP) of Tanzania in 2008?
Your response must be concise. -28.57. What is the difference between the Value added (% of GDP) in High income: OECD in 2007 and the Value added (% of GDP) in Kazakhstan in 2008?
Your answer should be very brief. -4.33. What is the difference between the Value added (% of GDP) in High income: OECD in 2007 and the Value added (% of GDP) in Slovenia in 2008?
Provide a short and direct response. -0.51. What is the difference between the Value added (% of GDP) in High income: OECD in 2007 and the Value added (% of GDP) in Tanzania in 2008?
Your answer should be very brief. -29.45. What is the difference between the Value added (% of GDP) of Kazakhstan in 2007 and the Value added (% of GDP) of Slovenia in 2008?
Your answer should be compact. 4.21. What is the difference between the Value added (% of GDP) of Kazakhstan in 2007 and the Value added (% of GDP) of Tanzania in 2008?
Offer a very short reply. -24.74. What is the difference between the Value added (% of GDP) in Slovenia in 2007 and the Value added (% of GDP) in Tanzania in 2008?
Your answer should be compact. -28.69. What is the average Value added (% of GDP) of High income: OECD per year?
Your answer should be compact. 1.53. What is the average Value added (% of GDP) in Kazakhstan per year?
Give a very brief answer. 7.31. What is the average Value added (% of GDP) in Slovenia per year?
Ensure brevity in your answer.  2.51. What is the average Value added (% of GDP) in Tanzania per year?
Your response must be concise. 31.53. In the year 2001, what is the difference between the Value added (% of GDP) in High income: OECD and Value added (% of GDP) in Kazakhstan?
Provide a short and direct response. -7.62. In the year 2001, what is the difference between the Value added (% of GDP) of High income: OECD and Value added (% of GDP) of Slovenia?
Your response must be concise. -1.22. In the year 2001, what is the difference between the Value added (% of GDP) of High income: OECD and Value added (% of GDP) of Tanzania?
Your answer should be very brief. -31.12. In the year 2001, what is the difference between the Value added (% of GDP) of Kazakhstan and Value added (% of GDP) of Slovenia?
Make the answer very short. 6.4. In the year 2001, what is the difference between the Value added (% of GDP) in Kazakhstan and Value added (% of GDP) in Tanzania?
Provide a short and direct response. -23.49. In the year 2001, what is the difference between the Value added (% of GDP) of Slovenia and Value added (% of GDP) of Tanzania?
Provide a short and direct response. -29.89. In the year 2002, what is the difference between the Value added (% of GDP) in High income: OECD and Value added (% of GDP) in Kazakhstan?
Provide a succinct answer. -7. In the year 2002, what is the difference between the Value added (% of GDP) in High income: OECD and Value added (% of GDP) in Slovenia?
Keep it short and to the point. -1.58. In the year 2002, what is the difference between the Value added (% of GDP) of High income: OECD and Value added (% of GDP) of Tanzania?
Your response must be concise. -30.84. In the year 2002, what is the difference between the Value added (% of GDP) of Kazakhstan and Value added (% of GDP) of Slovenia?
Keep it short and to the point. 5.41. In the year 2002, what is the difference between the Value added (% of GDP) of Kazakhstan and Value added (% of GDP) of Tanzania?
Your answer should be compact. -23.84. In the year 2002, what is the difference between the Value added (% of GDP) in Slovenia and Value added (% of GDP) in Tanzania?
Your answer should be very brief. -29.25. In the year 2003, what is the difference between the Value added (% of GDP) of High income: OECD and Value added (% of GDP) of Kazakhstan?
Make the answer very short. -6.82. In the year 2003, what is the difference between the Value added (% of GDP) of High income: OECD and Value added (% of GDP) of Slovenia?
Make the answer very short. -0.8. In the year 2003, what is the difference between the Value added (% of GDP) in High income: OECD and Value added (% of GDP) in Tanzania?
Your answer should be compact. -30.91. In the year 2003, what is the difference between the Value added (% of GDP) of Kazakhstan and Value added (% of GDP) of Slovenia?
Offer a very short reply. 6.02. In the year 2003, what is the difference between the Value added (% of GDP) of Kazakhstan and Value added (% of GDP) of Tanzania?
Give a very brief answer. -24.09. In the year 2003, what is the difference between the Value added (% of GDP) in Slovenia and Value added (% of GDP) in Tanzania?
Make the answer very short. -30.11. In the year 2004, what is the difference between the Value added (% of GDP) in High income: OECD and Value added (% of GDP) in Kazakhstan?
Give a very brief answer. -5.92. In the year 2004, what is the difference between the Value added (% of GDP) of High income: OECD and Value added (% of GDP) of Slovenia?
Your response must be concise. -0.95. In the year 2004, what is the difference between the Value added (% of GDP) in High income: OECD and Value added (% of GDP) in Tanzania?
Offer a terse response. -31.67. In the year 2004, what is the difference between the Value added (% of GDP) of Kazakhstan and Value added (% of GDP) of Slovenia?
Your answer should be compact. 4.98. In the year 2004, what is the difference between the Value added (% of GDP) of Kazakhstan and Value added (% of GDP) of Tanzania?
Make the answer very short. -25.75. In the year 2004, what is the difference between the Value added (% of GDP) in Slovenia and Value added (% of GDP) in Tanzania?
Your response must be concise. -30.73. In the year 2005, what is the difference between the Value added (% of GDP) in High income: OECD and Value added (% of GDP) in Kazakhstan?
Provide a succinct answer. -5.32. In the year 2005, what is the difference between the Value added (% of GDP) of High income: OECD and Value added (% of GDP) of Slovenia?
Your answer should be compact. -1.13. In the year 2005, what is the difference between the Value added (% of GDP) in High income: OECD and Value added (% of GDP) in Tanzania?
Your answer should be very brief. -28.99. In the year 2005, what is the difference between the Value added (% of GDP) in Kazakhstan and Value added (% of GDP) in Slovenia?
Your answer should be compact. 4.19. In the year 2005, what is the difference between the Value added (% of GDP) of Kazakhstan and Value added (% of GDP) of Tanzania?
Your answer should be compact. -23.68. In the year 2005, what is the difference between the Value added (% of GDP) of Slovenia and Value added (% of GDP) of Tanzania?
Offer a terse response. -27.86. In the year 2006, what is the difference between the Value added (% of GDP) in High income: OECD and Value added (% of GDP) in Kazakhstan?
Keep it short and to the point. -4.51. In the year 2006, what is the difference between the Value added (% of GDP) in High income: OECD and Value added (% of GDP) in Slovenia?
Your answer should be very brief. -0.89. In the year 2006, what is the difference between the Value added (% of GDP) of High income: OECD and Value added (% of GDP) of Tanzania?
Make the answer very short. -29.59. In the year 2006, what is the difference between the Value added (% of GDP) of Kazakhstan and Value added (% of GDP) of Slovenia?
Ensure brevity in your answer.  3.61. In the year 2006, what is the difference between the Value added (% of GDP) in Kazakhstan and Value added (% of GDP) in Tanzania?
Your response must be concise. -25.09. In the year 2006, what is the difference between the Value added (% of GDP) of Slovenia and Value added (% of GDP) of Tanzania?
Provide a succinct answer. -28.7. In the year 2007, what is the difference between the Value added (% of GDP) in High income: OECD and Value added (% of GDP) in Kazakhstan?
Your answer should be very brief. -4.71. In the year 2007, what is the difference between the Value added (% of GDP) in High income: OECD and Value added (% of GDP) in Slovenia?
Your answer should be compact. -0.76. In the year 2007, what is the difference between the Value added (% of GDP) in High income: OECD and Value added (% of GDP) in Tanzania?
Give a very brief answer. -27.4. In the year 2007, what is the difference between the Value added (% of GDP) in Kazakhstan and Value added (% of GDP) in Slovenia?
Your answer should be compact. 3.96. In the year 2007, what is the difference between the Value added (% of GDP) in Kazakhstan and Value added (% of GDP) in Tanzania?
Make the answer very short. -22.69. In the year 2007, what is the difference between the Value added (% of GDP) in Slovenia and Value added (% of GDP) in Tanzania?
Make the answer very short. -26.64. In the year 2008, what is the difference between the Value added (% of GDP) of High income: OECD and Value added (% of GDP) of Kazakhstan?
Your answer should be compact. -4.33. In the year 2008, what is the difference between the Value added (% of GDP) of High income: OECD and Value added (% of GDP) of Slovenia?
Your answer should be very brief. -0.5. In the year 2008, what is the difference between the Value added (% of GDP) of High income: OECD and Value added (% of GDP) of Tanzania?
Your answer should be very brief. -29.45. In the year 2008, what is the difference between the Value added (% of GDP) in Kazakhstan and Value added (% of GDP) in Slovenia?
Your response must be concise. 3.83. In the year 2008, what is the difference between the Value added (% of GDP) in Kazakhstan and Value added (% of GDP) in Tanzania?
Give a very brief answer. -25.12. In the year 2008, what is the difference between the Value added (% of GDP) of Slovenia and Value added (% of GDP) of Tanzania?
Make the answer very short. -28.94. What is the ratio of the Value added (% of GDP) of High income: OECD in 2001 to that in 2002?
Make the answer very short. 1.08. What is the ratio of the Value added (% of GDP) of Kazakhstan in 2001 to that in 2002?
Give a very brief answer. 1.09. What is the ratio of the Value added (% of GDP) in Slovenia in 2001 to that in 2002?
Your answer should be compact. 0.93. What is the ratio of the Value added (% of GDP) in Tanzania in 2001 to that in 2002?
Your answer should be very brief. 1.01. What is the ratio of the Value added (% of GDP) in High income: OECD in 2001 to that in 2003?
Your response must be concise. 1.08. What is the ratio of the Value added (% of GDP) in Kazakhstan in 2001 to that in 2003?
Your response must be concise. 1.11. What is the ratio of the Value added (% of GDP) in Slovenia in 2001 to that in 2003?
Your response must be concise. 1.23. What is the ratio of the Value added (% of GDP) in Tanzania in 2001 to that in 2003?
Your response must be concise. 1.01. What is the ratio of the Value added (% of GDP) of High income: OECD in 2001 to that in 2004?
Give a very brief answer. 1.06. What is the ratio of the Value added (% of GDP) in Kazakhstan in 2001 to that in 2004?
Make the answer very short. 1.24. What is the ratio of the Value added (% of GDP) of Slovenia in 2001 to that in 2004?
Your response must be concise. 1.14. What is the ratio of the Value added (% of GDP) of Tanzania in 2001 to that in 2004?
Provide a short and direct response. 0.99. What is the ratio of the Value added (% of GDP) of High income: OECD in 2001 to that in 2005?
Offer a very short reply. 1.19. What is the ratio of the Value added (% of GDP) of Kazakhstan in 2001 to that in 2005?
Ensure brevity in your answer.  1.38. What is the ratio of the Value added (% of GDP) in Slovenia in 2001 to that in 2005?
Make the answer very short. 1.14. What is the ratio of the Value added (% of GDP) in Tanzania in 2001 to that in 2005?
Your response must be concise. 1.08. What is the ratio of the Value added (% of GDP) of High income: OECD in 2001 to that in 2006?
Your answer should be very brief. 1.28. What is the ratio of the Value added (% of GDP) in Kazakhstan in 2001 to that in 2006?
Provide a succinct answer. 1.59. What is the ratio of the Value added (% of GDP) of Slovenia in 2001 to that in 2006?
Give a very brief answer. 1.31. What is the ratio of the Value added (% of GDP) of Tanzania in 2001 to that in 2006?
Your answer should be very brief. 1.06. What is the ratio of the Value added (% of GDP) in High income: OECD in 2001 to that in 2007?
Provide a succinct answer. 1.27. What is the ratio of the Value added (% of GDP) in Kazakhstan in 2001 to that in 2007?
Offer a terse response. 1.54. What is the ratio of the Value added (% of GDP) of Slovenia in 2001 to that in 2007?
Make the answer very short. 1.39. What is the ratio of the Value added (% of GDP) of Tanzania in 2001 to that in 2007?
Offer a very short reply. 1.14. What is the ratio of the Value added (% of GDP) in High income: OECD in 2001 to that in 2008?
Your response must be concise. 1.26. What is the ratio of the Value added (% of GDP) in Kazakhstan in 2001 to that in 2008?
Give a very brief answer. 1.64. What is the ratio of the Value added (% of GDP) of Slovenia in 2001 to that in 2008?
Provide a short and direct response. 1.57. What is the ratio of the Value added (% of GDP) of Tanzania in 2001 to that in 2008?
Offer a terse response. 1.07. What is the ratio of the Value added (% of GDP) of Kazakhstan in 2002 to that in 2003?
Make the answer very short. 1.02. What is the ratio of the Value added (% of GDP) of Slovenia in 2002 to that in 2003?
Your answer should be very brief. 1.33. What is the ratio of the Value added (% of GDP) of High income: OECD in 2002 to that in 2004?
Offer a terse response. 0.98. What is the ratio of the Value added (% of GDP) in Kazakhstan in 2002 to that in 2004?
Provide a succinct answer. 1.14. What is the ratio of the Value added (% of GDP) in Slovenia in 2002 to that in 2004?
Keep it short and to the point. 1.23. What is the ratio of the Value added (% of GDP) in Tanzania in 2002 to that in 2004?
Keep it short and to the point. 0.97. What is the ratio of the Value added (% of GDP) in High income: OECD in 2002 to that in 2005?
Your answer should be compact. 1.1. What is the ratio of the Value added (% of GDP) in Kazakhstan in 2002 to that in 2005?
Provide a succinct answer. 1.27. What is the ratio of the Value added (% of GDP) in Slovenia in 2002 to that in 2005?
Keep it short and to the point. 1.23. What is the ratio of the Value added (% of GDP) of Tanzania in 2002 to that in 2005?
Your answer should be very brief. 1.07. What is the ratio of the Value added (% of GDP) in High income: OECD in 2002 to that in 2006?
Offer a very short reply. 1.18. What is the ratio of the Value added (% of GDP) in Kazakhstan in 2002 to that in 2006?
Give a very brief answer. 1.47. What is the ratio of the Value added (% of GDP) of Slovenia in 2002 to that in 2006?
Your response must be concise. 1.41. What is the ratio of the Value added (% of GDP) in Tanzania in 2002 to that in 2006?
Provide a short and direct response. 1.05. What is the ratio of the Value added (% of GDP) of High income: OECD in 2002 to that in 2007?
Your response must be concise. 1.17. What is the ratio of the Value added (% of GDP) in Kazakhstan in 2002 to that in 2007?
Offer a very short reply. 1.41. What is the ratio of the Value added (% of GDP) in Slovenia in 2002 to that in 2007?
Your answer should be very brief. 1.5. What is the ratio of the Value added (% of GDP) in Tanzania in 2002 to that in 2007?
Provide a short and direct response. 1.13. What is the ratio of the Value added (% of GDP) in High income: OECD in 2002 to that in 2008?
Give a very brief answer. 1.17. What is the ratio of the Value added (% of GDP) of Kazakhstan in 2002 to that in 2008?
Ensure brevity in your answer.  1.51. What is the ratio of the Value added (% of GDP) of Slovenia in 2002 to that in 2008?
Your answer should be compact. 1.7. What is the ratio of the Value added (% of GDP) in Tanzania in 2002 to that in 2008?
Offer a terse response. 1.05. What is the ratio of the Value added (% of GDP) in High income: OECD in 2003 to that in 2004?
Your answer should be very brief. 0.98. What is the ratio of the Value added (% of GDP) in Kazakhstan in 2003 to that in 2004?
Your response must be concise. 1.11. What is the ratio of the Value added (% of GDP) of Slovenia in 2003 to that in 2004?
Keep it short and to the point. 0.93. What is the ratio of the Value added (% of GDP) in Tanzania in 2003 to that in 2004?
Provide a short and direct response. 0.98. What is the ratio of the Value added (% of GDP) in High income: OECD in 2003 to that in 2005?
Your answer should be compact. 1.1. What is the ratio of the Value added (% of GDP) in Kazakhstan in 2003 to that in 2005?
Your response must be concise. 1.24. What is the ratio of the Value added (% of GDP) of Slovenia in 2003 to that in 2005?
Offer a very short reply. 0.93. What is the ratio of the Value added (% of GDP) in Tanzania in 2003 to that in 2005?
Give a very brief answer. 1.07. What is the ratio of the Value added (% of GDP) in High income: OECD in 2003 to that in 2006?
Your answer should be compact. 1.18. What is the ratio of the Value added (% of GDP) in Kazakhstan in 2003 to that in 2006?
Keep it short and to the point. 1.43. What is the ratio of the Value added (% of GDP) of Slovenia in 2003 to that in 2006?
Offer a terse response. 1.06. What is the ratio of the Value added (% of GDP) in Tanzania in 2003 to that in 2006?
Keep it short and to the point. 1.05. What is the ratio of the Value added (% of GDP) of High income: OECD in 2003 to that in 2007?
Provide a succinct answer. 1.17. What is the ratio of the Value added (% of GDP) of Kazakhstan in 2003 to that in 2007?
Keep it short and to the point. 1.38. What is the ratio of the Value added (% of GDP) of Slovenia in 2003 to that in 2007?
Keep it short and to the point. 1.13. What is the ratio of the Value added (% of GDP) of Tanzania in 2003 to that in 2007?
Make the answer very short. 1.13. What is the ratio of the Value added (% of GDP) of High income: OECD in 2003 to that in 2008?
Give a very brief answer. 1.17. What is the ratio of the Value added (% of GDP) of Kazakhstan in 2003 to that in 2008?
Ensure brevity in your answer.  1.48. What is the ratio of the Value added (% of GDP) in Slovenia in 2003 to that in 2008?
Provide a short and direct response. 1.28. What is the ratio of the Value added (% of GDP) in Tanzania in 2003 to that in 2008?
Give a very brief answer. 1.05. What is the ratio of the Value added (% of GDP) of High income: OECD in 2004 to that in 2005?
Ensure brevity in your answer.  1.12. What is the ratio of the Value added (% of GDP) in Kazakhstan in 2004 to that in 2005?
Offer a terse response. 1.12. What is the ratio of the Value added (% of GDP) in Slovenia in 2004 to that in 2005?
Provide a succinct answer. 1. What is the ratio of the Value added (% of GDP) in Tanzania in 2004 to that in 2005?
Your answer should be very brief. 1.09. What is the ratio of the Value added (% of GDP) of High income: OECD in 2004 to that in 2006?
Your response must be concise. 1.21. What is the ratio of the Value added (% of GDP) in Kazakhstan in 2004 to that in 2006?
Provide a short and direct response. 1.29. What is the ratio of the Value added (% of GDP) of Slovenia in 2004 to that in 2006?
Offer a terse response. 1.15. What is the ratio of the Value added (% of GDP) of Tanzania in 2004 to that in 2006?
Your response must be concise. 1.08. What is the ratio of the Value added (% of GDP) in High income: OECD in 2004 to that in 2007?
Your response must be concise. 1.2. What is the ratio of the Value added (% of GDP) of Kazakhstan in 2004 to that in 2007?
Offer a terse response. 1.24. What is the ratio of the Value added (% of GDP) in Slovenia in 2004 to that in 2007?
Make the answer very short. 1.22. What is the ratio of the Value added (% of GDP) in Tanzania in 2004 to that in 2007?
Offer a terse response. 1.16. What is the ratio of the Value added (% of GDP) of High income: OECD in 2004 to that in 2008?
Your answer should be very brief. 1.19. What is the ratio of the Value added (% of GDP) in Kazakhstan in 2004 to that in 2008?
Offer a terse response. 1.33. What is the ratio of the Value added (% of GDP) of Slovenia in 2004 to that in 2008?
Your answer should be compact. 1.38. What is the ratio of the Value added (% of GDP) of Tanzania in 2004 to that in 2008?
Ensure brevity in your answer.  1.08. What is the ratio of the Value added (% of GDP) of High income: OECD in 2005 to that in 2006?
Provide a short and direct response. 1.07. What is the ratio of the Value added (% of GDP) in Kazakhstan in 2005 to that in 2006?
Your answer should be compact. 1.15. What is the ratio of the Value added (% of GDP) of Slovenia in 2005 to that in 2006?
Your answer should be compact. 1.15. What is the ratio of the Value added (% of GDP) in Tanzania in 2005 to that in 2006?
Give a very brief answer. 0.98. What is the ratio of the Value added (% of GDP) of High income: OECD in 2005 to that in 2007?
Offer a terse response. 1.06. What is the ratio of the Value added (% of GDP) in Kazakhstan in 2005 to that in 2007?
Ensure brevity in your answer.  1.11. What is the ratio of the Value added (% of GDP) of Slovenia in 2005 to that in 2007?
Offer a very short reply. 1.22. What is the ratio of the Value added (% of GDP) of Tanzania in 2005 to that in 2007?
Provide a succinct answer. 1.06. What is the ratio of the Value added (% of GDP) of High income: OECD in 2005 to that in 2008?
Your answer should be very brief. 1.06. What is the ratio of the Value added (% of GDP) of Kazakhstan in 2005 to that in 2008?
Give a very brief answer. 1.19. What is the ratio of the Value added (% of GDP) of Slovenia in 2005 to that in 2008?
Make the answer very short. 1.38. What is the ratio of the Value added (% of GDP) of Tanzania in 2005 to that in 2008?
Your answer should be compact. 0.99. What is the ratio of the Value added (% of GDP) in Kazakhstan in 2006 to that in 2007?
Offer a very short reply. 0.96. What is the ratio of the Value added (% of GDP) of Slovenia in 2006 to that in 2007?
Offer a very short reply. 1.06. What is the ratio of the Value added (% of GDP) of Tanzania in 2006 to that in 2007?
Offer a very short reply. 1.08. What is the ratio of the Value added (% of GDP) in Kazakhstan in 2006 to that in 2008?
Your answer should be compact. 1.03. What is the ratio of the Value added (% of GDP) of Slovenia in 2006 to that in 2008?
Offer a terse response. 1.2. What is the ratio of the Value added (% of GDP) of High income: OECD in 2007 to that in 2008?
Offer a very short reply. 1. What is the ratio of the Value added (% of GDP) in Kazakhstan in 2007 to that in 2008?
Your response must be concise. 1.07. What is the ratio of the Value added (% of GDP) in Slovenia in 2007 to that in 2008?
Your response must be concise. 1.13. What is the ratio of the Value added (% of GDP) of Tanzania in 2007 to that in 2008?
Give a very brief answer. 0.93. What is the difference between the highest and the second highest Value added (% of GDP) in High income: OECD?
Give a very brief answer. 0.1. What is the difference between the highest and the second highest Value added (% of GDP) in Kazakhstan?
Offer a terse response. 0.76. What is the difference between the highest and the second highest Value added (% of GDP) of Slovenia?
Make the answer very short. 0.23. What is the difference between the highest and the second highest Value added (% of GDP) of Tanzania?
Ensure brevity in your answer.  0.46. What is the difference between the highest and the lowest Value added (% of GDP) in High income: OECD?
Your response must be concise. 0.38. What is the difference between the highest and the lowest Value added (% of GDP) of Kazakhstan?
Your response must be concise. 3.66. What is the difference between the highest and the lowest Value added (% of GDP) of Slovenia?
Your answer should be compact. 1.31. What is the difference between the highest and the lowest Value added (% of GDP) in Tanzania?
Offer a very short reply. 4.54. 